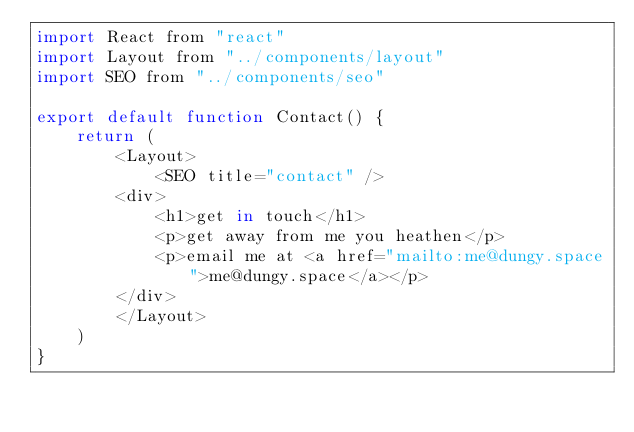<code> <loc_0><loc_0><loc_500><loc_500><_JavaScript_>import React from "react"
import Layout from "../components/layout"
import SEO from "../components/seo"

export default function Contact() {
    return (
        <Layout>
            <SEO title="contact" />
        <div>
            <h1>get in touch</h1>
            <p>get away from me you heathen</p>
            <p>email me at <a href="mailto:me@dungy.space">me@dungy.space</a></p>
        </div>
        </Layout>
    )
}</code> 